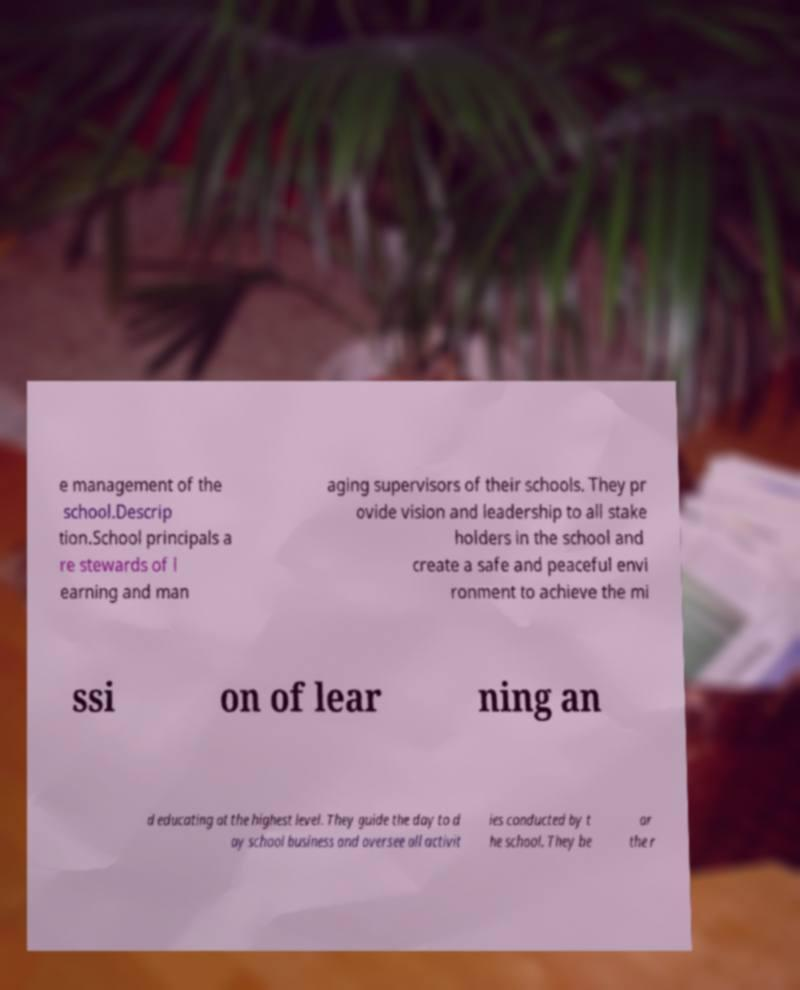What messages or text are displayed in this image? I need them in a readable, typed format. e management of the school.Descrip tion.School principals a re stewards of l earning and man aging supervisors of their schools. They pr ovide vision and leadership to all stake holders in the school and create a safe and peaceful envi ronment to achieve the mi ssi on of lear ning an d educating at the highest level. They guide the day to d ay school business and oversee all activit ies conducted by t he school. They be ar the r 